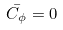Convert formula to latex. <formula><loc_0><loc_0><loc_500><loc_500>\bar { C _ { \phi } } = 0</formula> 